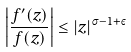<formula> <loc_0><loc_0><loc_500><loc_500>\left | \frac { f ^ { \prime } ( z ) } { f ( z ) } \right | \leq | z | ^ { \sigma - 1 + \varepsilon }</formula> 